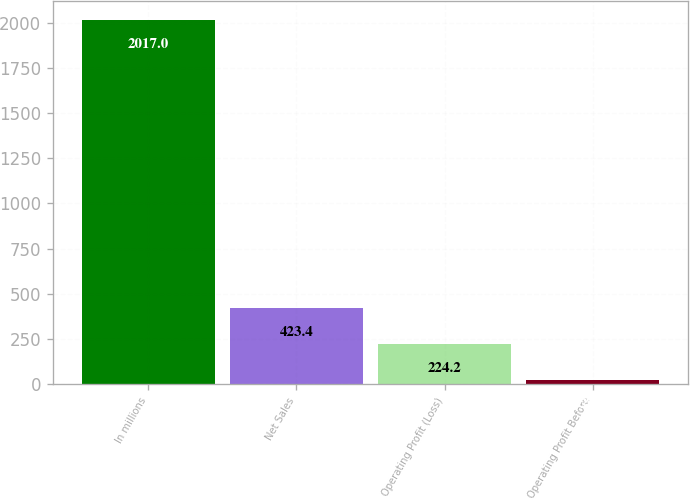Convert chart to OTSL. <chart><loc_0><loc_0><loc_500><loc_500><bar_chart><fcel>In millions<fcel>Net Sales<fcel>Operating Profit (Loss)<fcel>Operating Profit Before<nl><fcel>2017<fcel>423.4<fcel>224.2<fcel>25<nl></chart> 